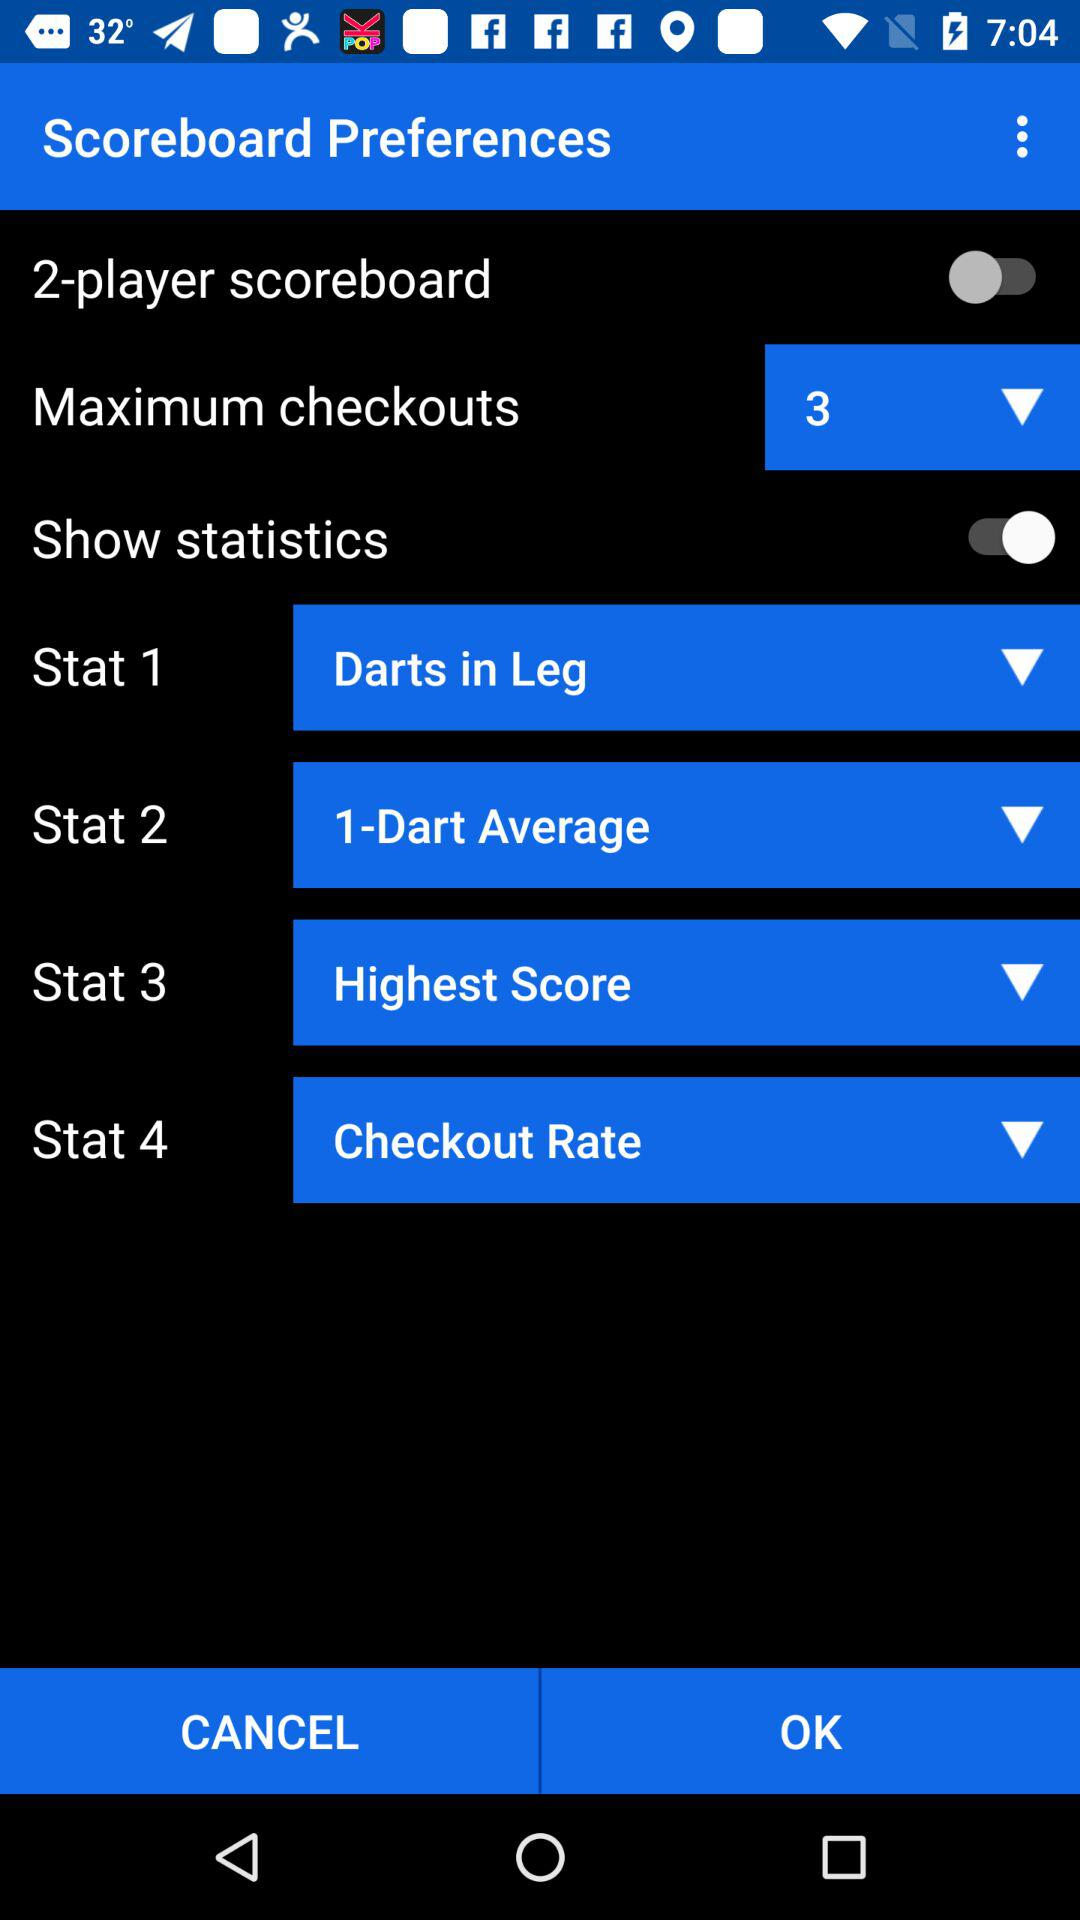What is the status of the "Show statistics"? The status is "on". 